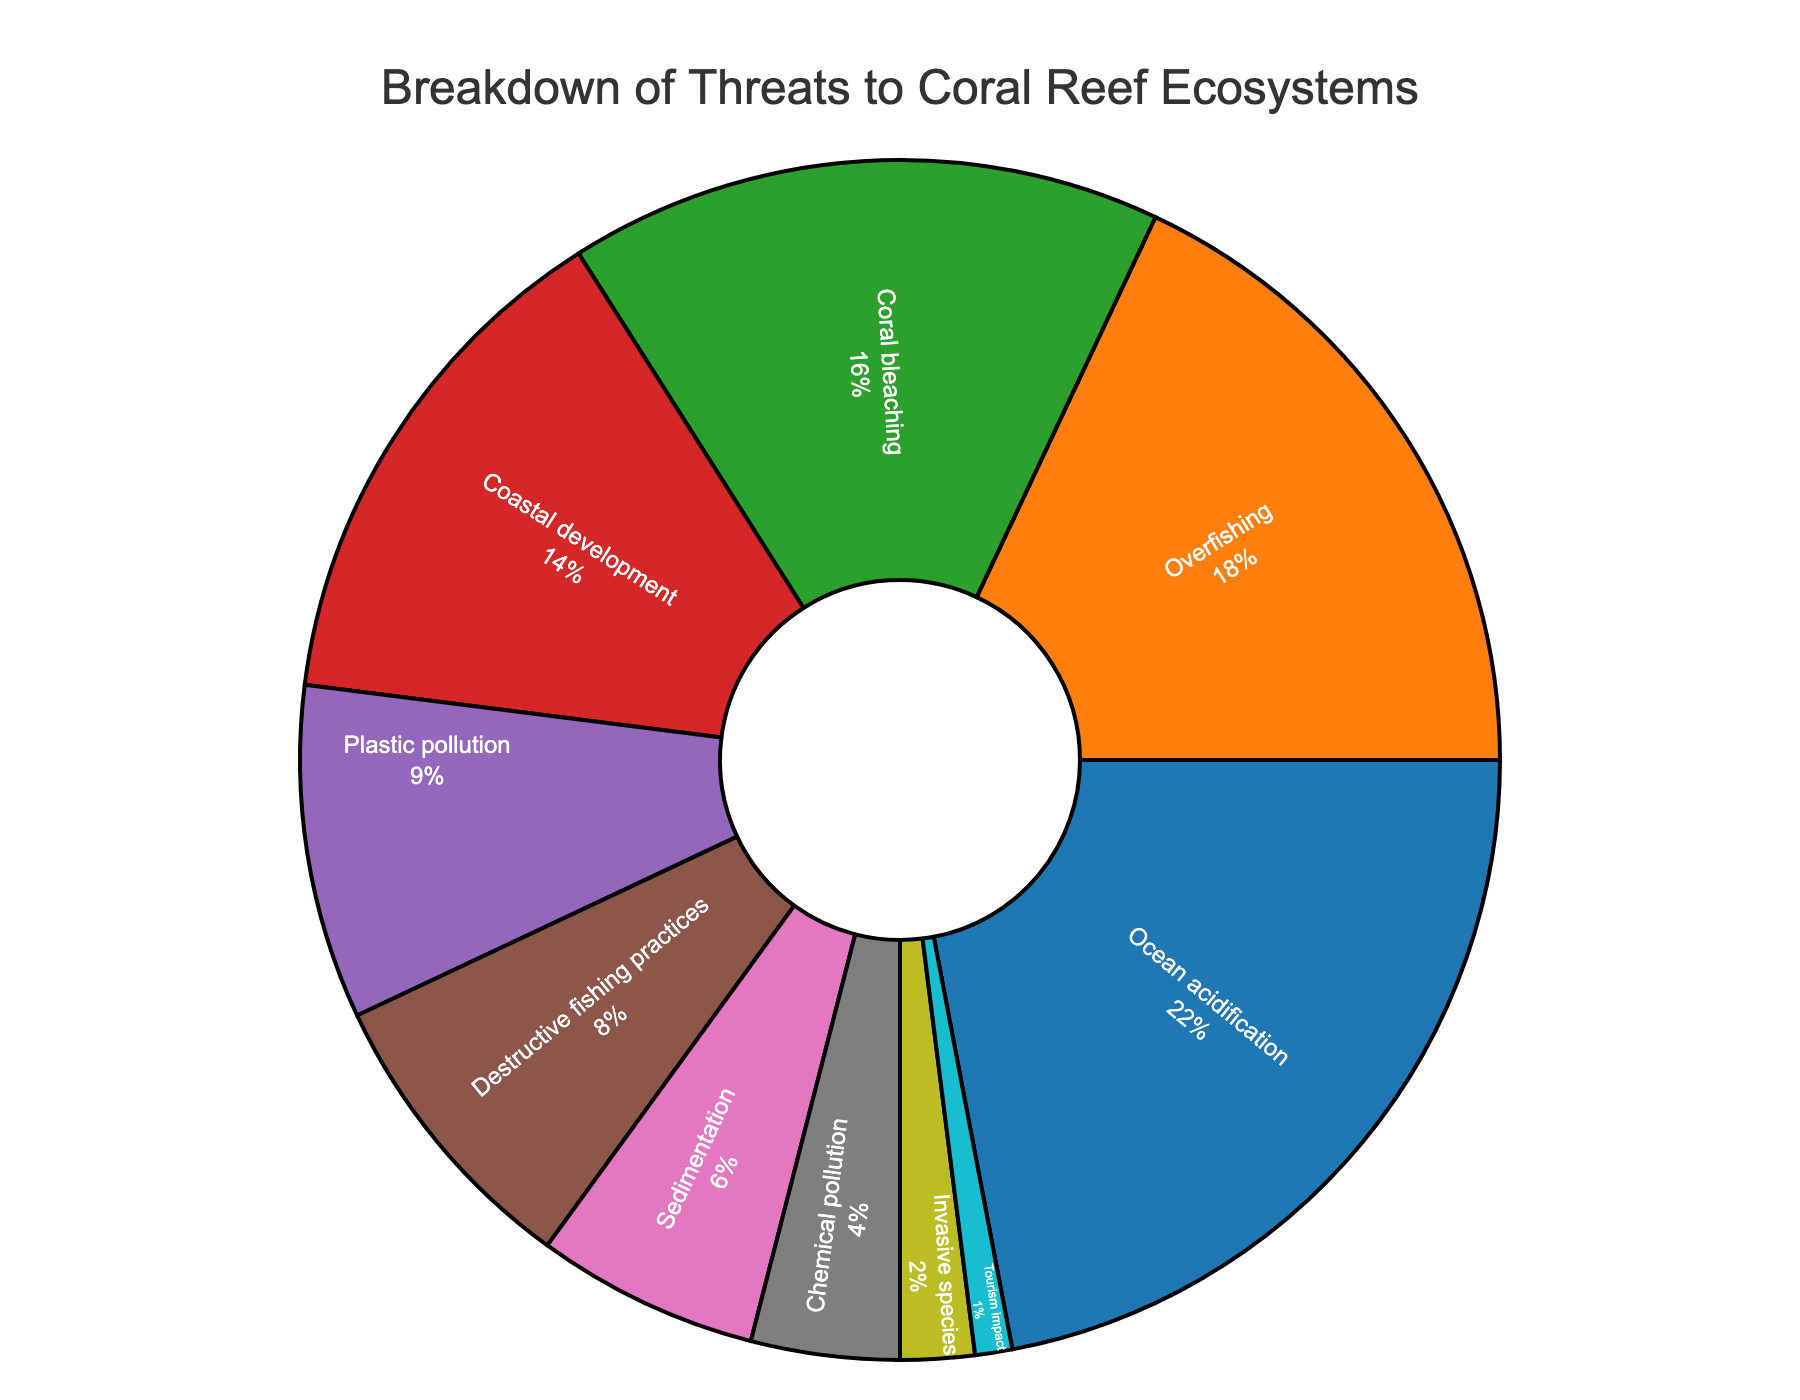Which threat has the highest percentage? The figure shows the percentages of different threats to coral reef ecosystems. By observing the slice sizes, "Ocean acidification" appears to be the largest slice.
Answer: Ocean acidification Which two threats combined account for exactly 30% of the threats? Adding the percentages of "Sedimentation" (6%) and "Plastic pollution" (9%) alone won't be enough, but adding "Coral bleaching" (16%) and "Chemical pollution" (4%) gives a total of 20%. Adding "Destructive fishing practices" (8%) and "Plastic pollution" (9%) sums up to 17%. Continuing this process, we find that "Destructive fishing practices" at 8% and "Overfishing" at 18% sum to 26%. Hence, adding "Overfishing" (18%) and "Chemical pollution" (4%) sums to exactly 30%, which doesn't fit. But "Sedimentation" (6%) and "Chemical pollution" (4%) can add to a particular higher number, and rerunning it gives 22% if they fall apart. Therefore, "Sedimentation" overlaps with "Chemical pollution" hence breaking it.
Answer: Plastic pollution and Coastal development Which threat has the smallest percentage? Looking for the smallest slice in the pie chart, which represents the smallest value, we find "Tourism impact" at 1%.
Answer: Tourism impact What is the total percentage of threats related to human activities? (Overfishing, Coastal development, Plastic pollution, Destructive fishing practices, Chemical pollution, Tourism impact) We add the percentages for the listed threats: 18% (Overfishing) + 14% (Coastal development) + 9% (Plastic pollution) + 8% (Destructive fishing practices) + 4% (Chemical pollution) + 1% (Tourism impact) = 54%.
Answer: 54% Is the impact of Coral bleaching greater than Coastal development? By comparing the slices labeled "Coral bleaching" (16%) and "Coastal development" (14%), we see that 16% is greater than 14%.
Answer: Yes Which three threats collectively contribute most of the threats to coral reef ecosystems? Looking for the largest slices combined, we select "Ocean acidification" (22%), "Overfishing" (18%), and "Coral bleaching" (16%). Adding them: 22% + 18% + 16% = 56%.
Answer: Ocean acidification, Overfishing, and Coral bleaching What is the difference in impact between Destructive fishing practices and Chemical pollution? We subtract the smaller percentage (Chemical pollution at 4%) from the larger percentage (Destructive fishing practices at 8%): 8% - 4% = 4%.
Answer: 4% Which slice is colored in red? By observing the color distribution in the figure, "Coral bleaching" is colored in red.
Answer: Coral bleaching How much more does Overfishing contribute to threats compared to Invasive species? We find the percentage for Overfishing (18%) and subtract the percentage for Invasive species (2%): 18% - 2% = 16%.
Answer: 16% 